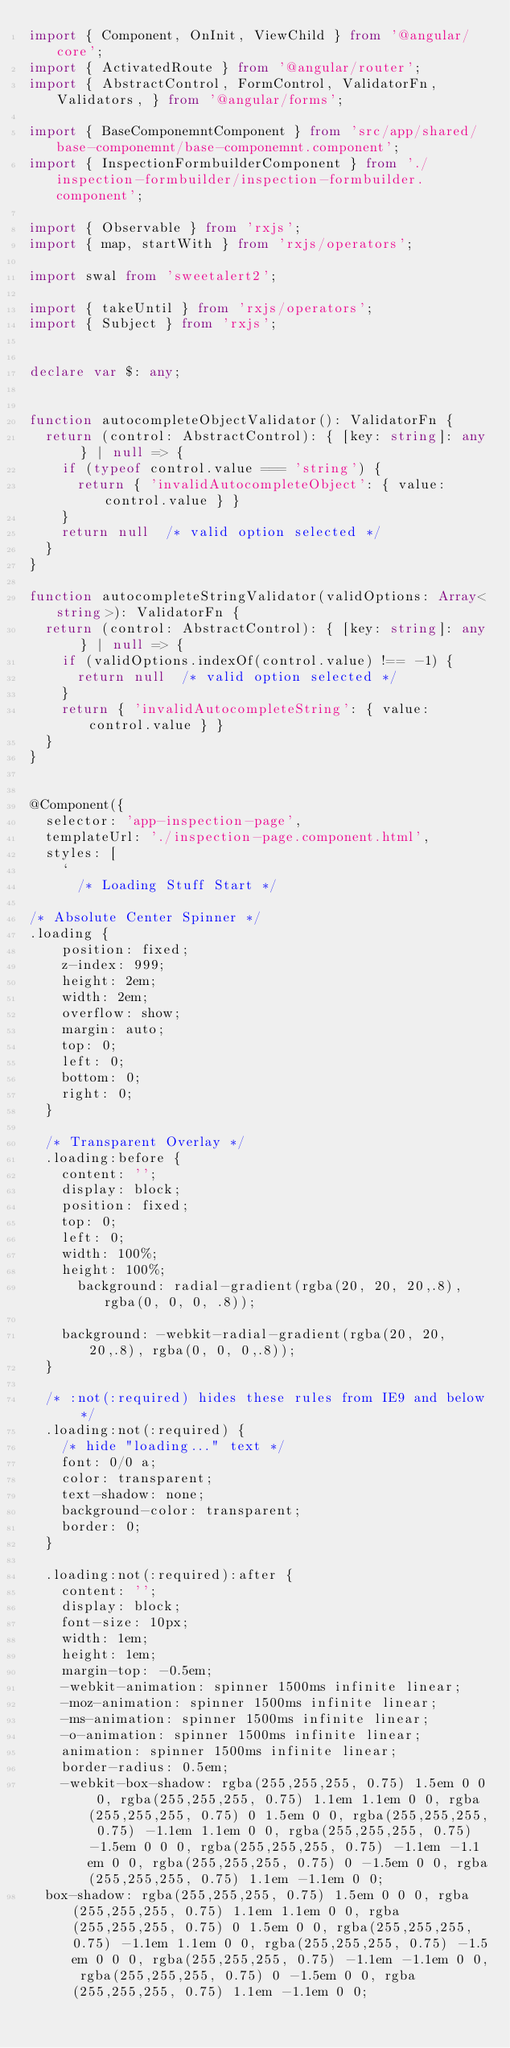Convert code to text. <code><loc_0><loc_0><loc_500><loc_500><_TypeScript_>import { Component, OnInit, ViewChild } from '@angular/core';
import { ActivatedRoute } from '@angular/router';
import { AbstractControl, FormControl, ValidatorFn, Validators, } from '@angular/forms';

import { BaseComponemntComponent } from 'src/app/shared/base-componemnt/base-componemnt.component';
import { InspectionFormbuilderComponent } from './inspection-formbuilder/inspection-formbuilder.component';

import { Observable } from 'rxjs';
import { map, startWith } from 'rxjs/operators';

import swal from 'sweetalert2';

import { takeUntil } from 'rxjs/operators';
import { Subject } from 'rxjs';


declare var $: any;


function autocompleteObjectValidator(): ValidatorFn {
  return (control: AbstractControl): { [key: string]: any } | null => {
    if (typeof control.value === 'string') {
      return { 'invalidAutocompleteObject': { value: control.value } }
    }
    return null  /* valid option selected */
  }
}

function autocompleteStringValidator(validOptions: Array<string>): ValidatorFn {
  return (control: AbstractControl): { [key: string]: any } | null => {
    if (validOptions.indexOf(control.value) !== -1) {
      return null  /* valid option selected */
    }
    return { 'invalidAutocompleteString': { value: control.value } }
  }
}


@Component({
  selector: 'app-inspection-page',
  templateUrl: './inspection-page.component.html',
  styles: [
    `
      /* Loading Stuff Start */

/* Absolute Center Spinner */
.loading {
    position: fixed;
    z-index: 999;
    height: 2em;
    width: 2em;
    overflow: show;
    margin: auto;
    top: 0;
    left: 0;
    bottom: 0;
    right: 0;
  }
  
  /* Transparent Overlay */
  .loading:before {
    content: '';
    display: block;
    position: fixed;
    top: 0;
    left: 0;
    width: 100%;
    height: 100%;
      background: radial-gradient(rgba(20, 20, 20,.8), rgba(0, 0, 0, .8));
  
    background: -webkit-radial-gradient(rgba(20, 20, 20,.8), rgba(0, 0, 0,.8));
  }
  
  /* :not(:required) hides these rules from IE9 and below */
  .loading:not(:required) {
    /* hide "loading..." text */
    font: 0/0 a;
    color: transparent;
    text-shadow: none;
    background-color: transparent;
    border: 0;
  }
  
  .loading:not(:required):after {
    content: '';
    display: block;
    font-size: 10px;
    width: 1em;
    height: 1em;
    margin-top: -0.5em;
    -webkit-animation: spinner 1500ms infinite linear;
    -moz-animation: spinner 1500ms infinite linear;
    -ms-animation: spinner 1500ms infinite linear;
    -o-animation: spinner 1500ms infinite linear;
    animation: spinner 1500ms infinite linear;
    border-radius: 0.5em;
    -webkit-box-shadow: rgba(255,255,255, 0.75) 1.5em 0 0 0, rgba(255,255,255, 0.75) 1.1em 1.1em 0 0, rgba(255,255,255, 0.75) 0 1.5em 0 0, rgba(255,255,255, 0.75) -1.1em 1.1em 0 0, rgba(255,255,255, 0.75) -1.5em 0 0 0, rgba(255,255,255, 0.75) -1.1em -1.1em 0 0, rgba(255,255,255, 0.75) 0 -1.5em 0 0, rgba(255,255,255, 0.75) 1.1em -1.1em 0 0;
  box-shadow: rgba(255,255,255, 0.75) 1.5em 0 0 0, rgba(255,255,255, 0.75) 1.1em 1.1em 0 0, rgba(255,255,255, 0.75) 0 1.5em 0 0, rgba(255,255,255, 0.75) -1.1em 1.1em 0 0, rgba(255,255,255, 0.75) -1.5em 0 0 0, rgba(255,255,255, 0.75) -1.1em -1.1em 0 0, rgba(255,255,255, 0.75) 0 -1.5em 0 0, rgba(255,255,255, 0.75) 1.1em -1.1em 0 0;</code> 